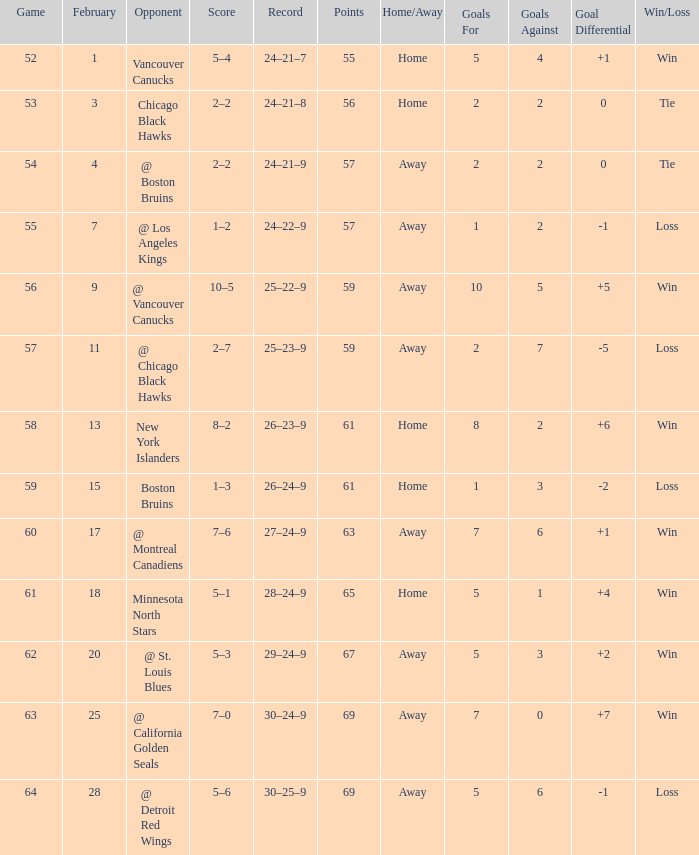How many february games had a record of 29–24–9? 20.0. 